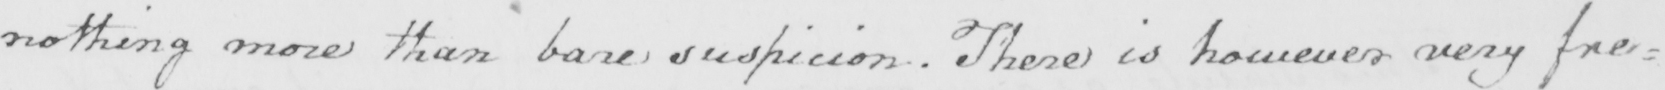What is written in this line of handwriting? nothing more than bare suspicion . There is however very fre= 